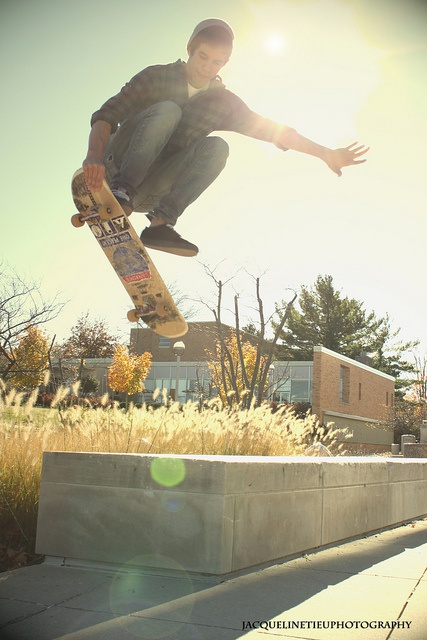Describe the objects in this image and their specific colors. I can see people in gray and tan tones and skateboard in gray and tan tones in this image. 